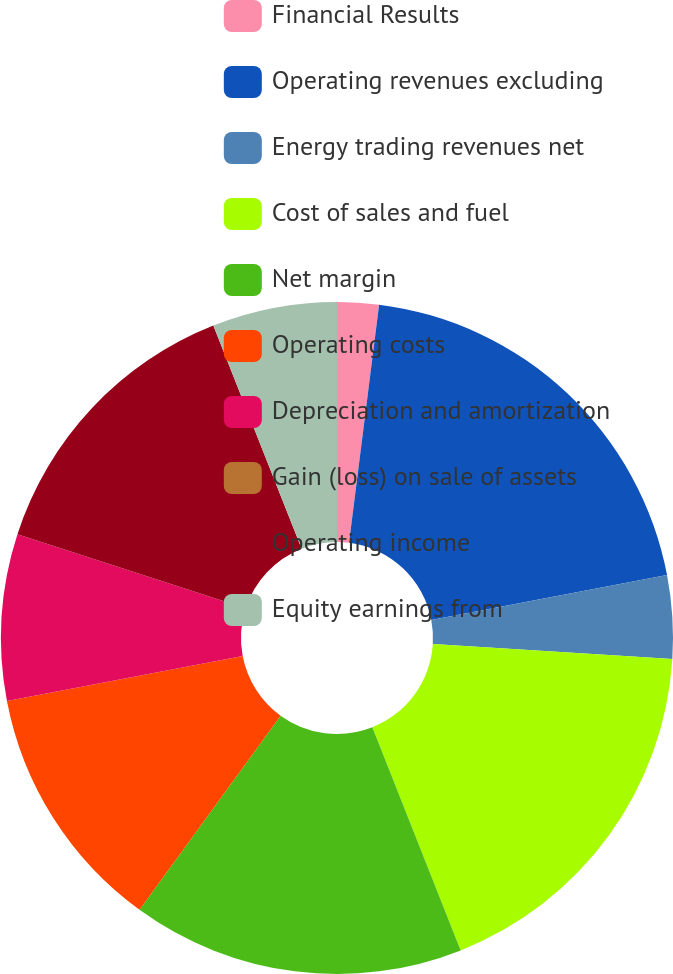Convert chart. <chart><loc_0><loc_0><loc_500><loc_500><pie_chart><fcel>Financial Results<fcel>Operating revenues excluding<fcel>Energy trading revenues net<fcel>Cost of sales and fuel<fcel>Net margin<fcel>Operating costs<fcel>Depreciation and amortization<fcel>Gain (loss) on sale of assets<fcel>Operating income<fcel>Equity earnings from<nl><fcel>2.0%<fcel>20.0%<fcel>4.0%<fcel>18.0%<fcel>16.0%<fcel>12.0%<fcel>8.0%<fcel>0.0%<fcel>14.0%<fcel>6.0%<nl></chart> 